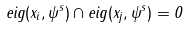Convert formula to latex. <formula><loc_0><loc_0><loc_500><loc_500>e i g ( x _ { i } , \psi ^ { s } ) \cap e i g ( x _ { j } , \psi ^ { s } ) = 0</formula> 